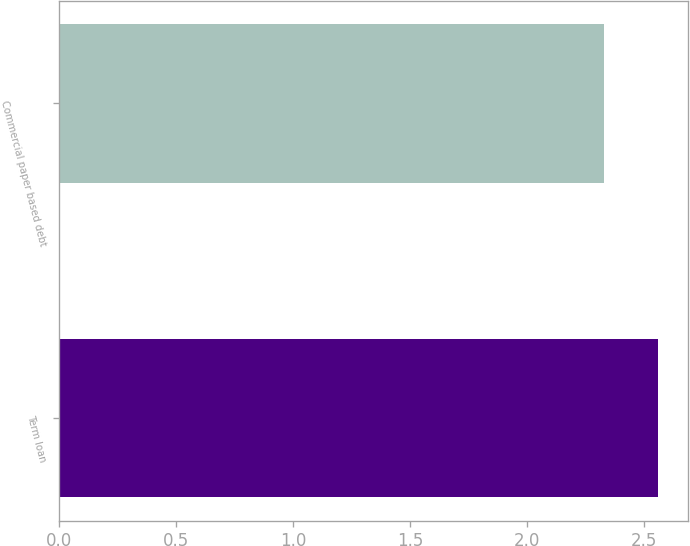Convert chart to OTSL. <chart><loc_0><loc_0><loc_500><loc_500><bar_chart><fcel>Term loan<fcel>Commercial paper based debt<nl><fcel>2.56<fcel>2.33<nl></chart> 